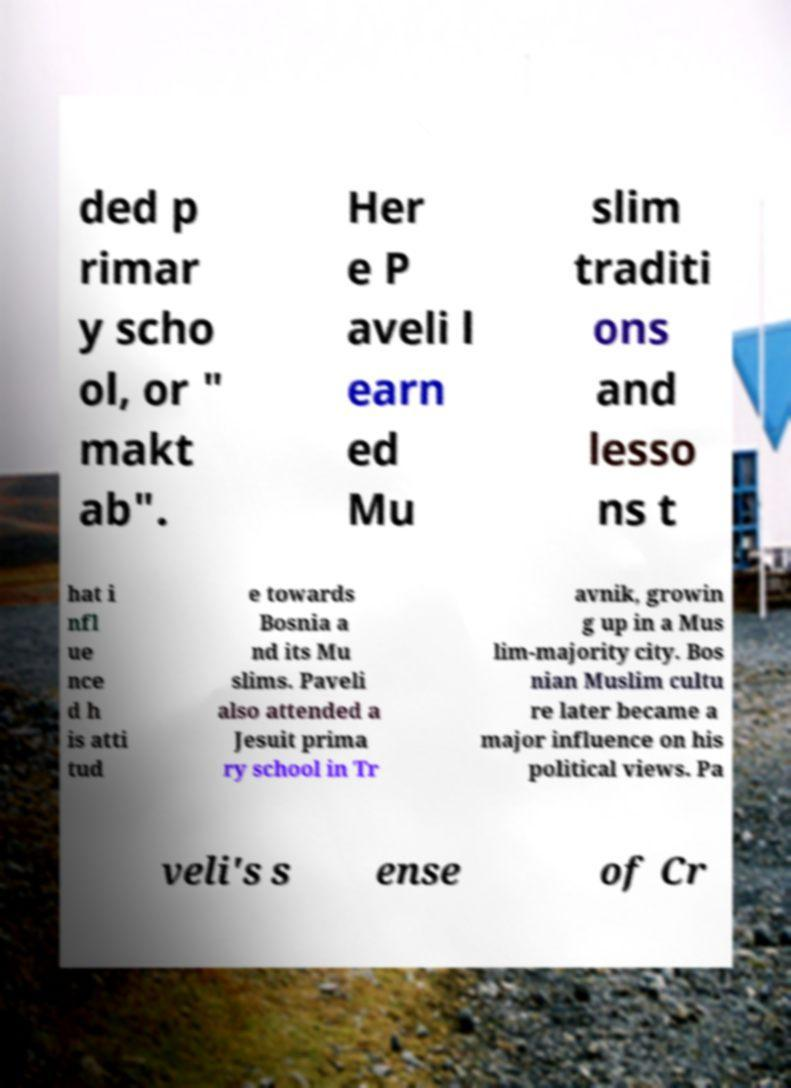I need the written content from this picture converted into text. Can you do that? ded p rimar y scho ol, or " makt ab". Her e P aveli l earn ed Mu slim traditi ons and lesso ns t hat i nfl ue nce d h is atti tud e towards Bosnia a nd its Mu slims. Paveli also attended a Jesuit prima ry school in Tr avnik, growin g up in a Mus lim-majority city. Bos nian Muslim cultu re later became a major influence on his political views. Pa veli's s ense of Cr 